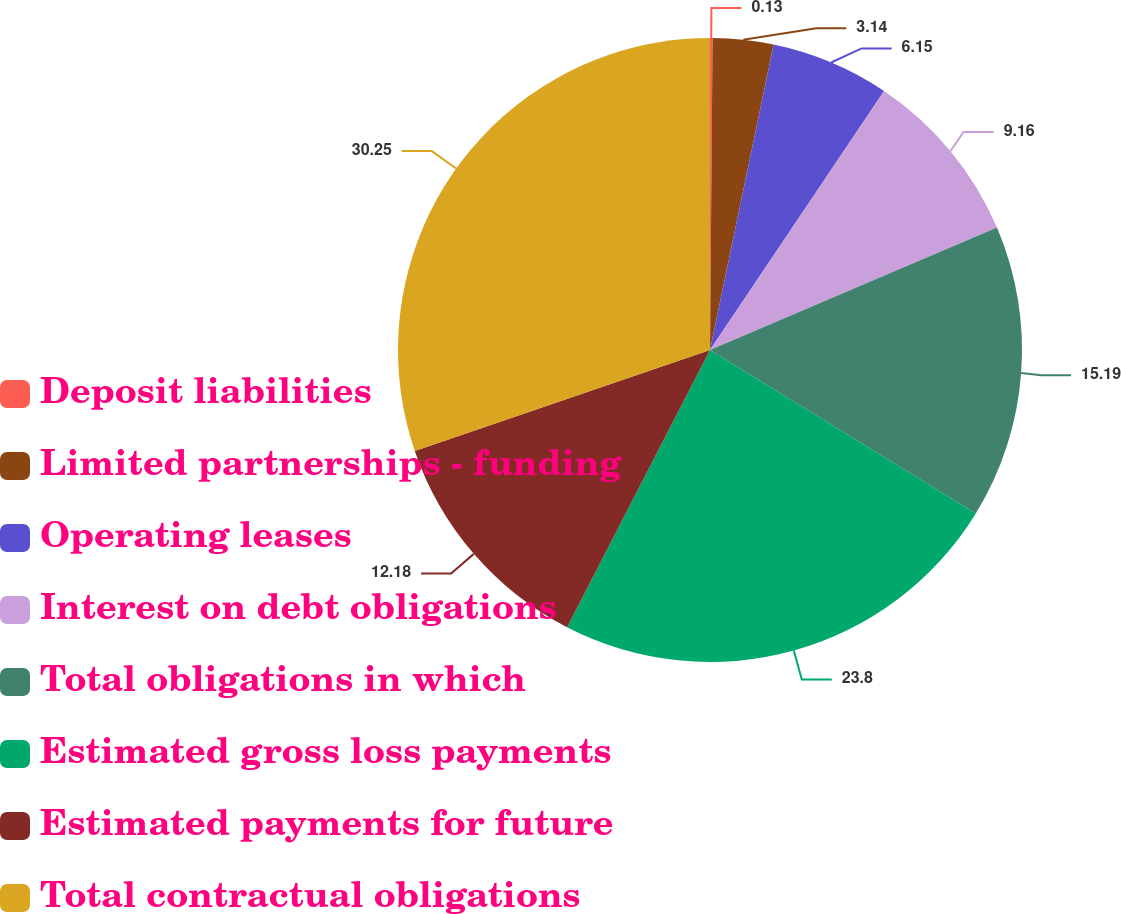<chart> <loc_0><loc_0><loc_500><loc_500><pie_chart><fcel>Deposit liabilities<fcel>Limited partnerships - funding<fcel>Operating leases<fcel>Interest on debt obligations<fcel>Total obligations in which<fcel>Estimated gross loss payments<fcel>Estimated payments for future<fcel>Total contractual obligations<nl><fcel>0.13%<fcel>3.14%<fcel>6.15%<fcel>9.16%<fcel>15.19%<fcel>23.8%<fcel>12.18%<fcel>30.24%<nl></chart> 